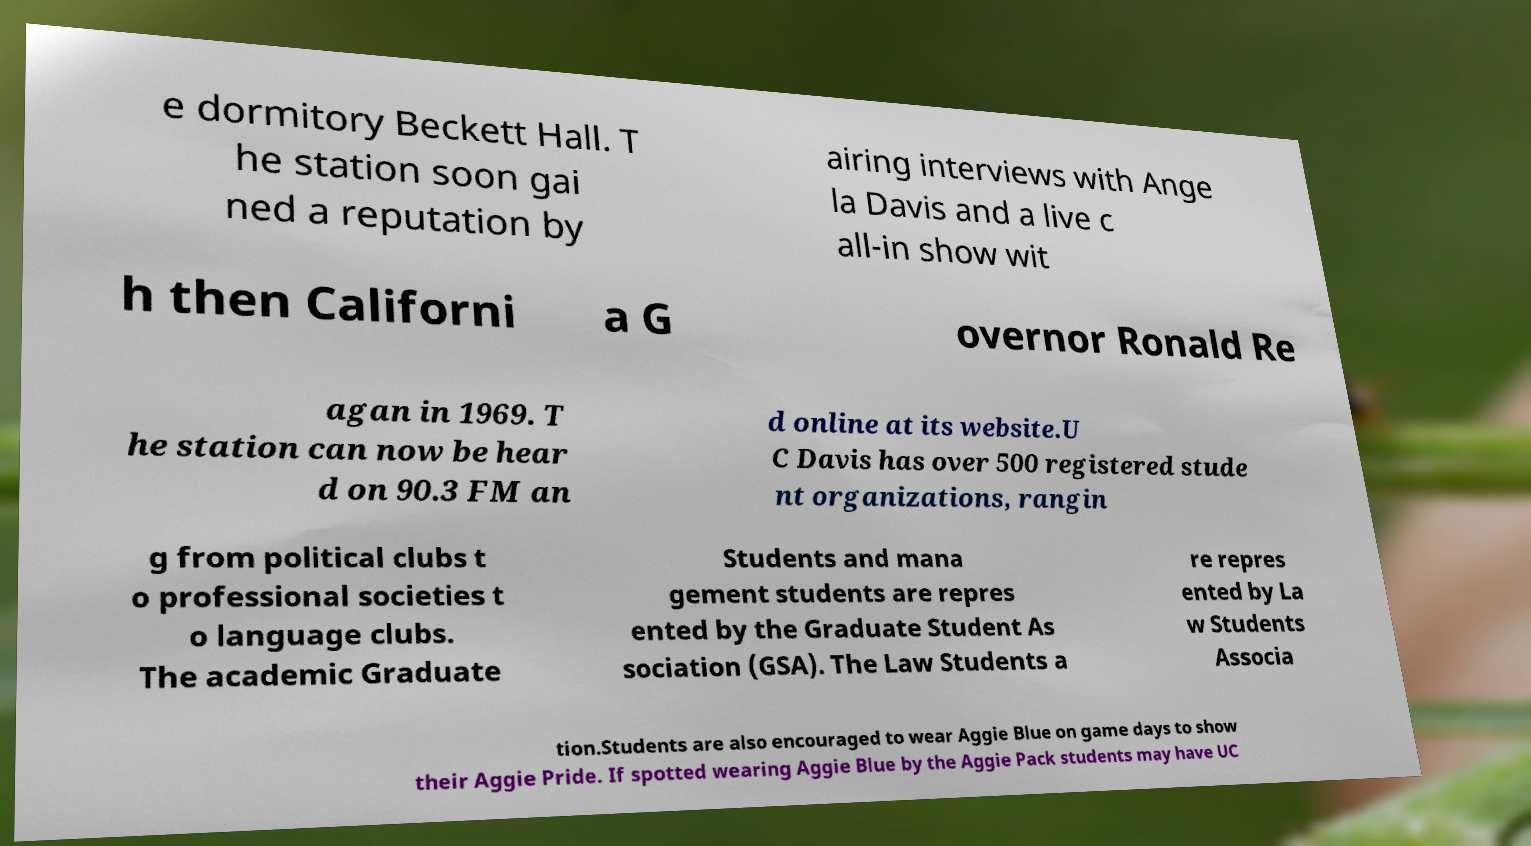Could you extract and type out the text from this image? e dormitory Beckett Hall. T he station soon gai ned a reputation by airing interviews with Ange la Davis and a live c all-in show wit h then Californi a G overnor Ronald Re agan in 1969. T he station can now be hear d on 90.3 FM an d online at its website.U C Davis has over 500 registered stude nt organizations, rangin g from political clubs t o professional societies t o language clubs. The academic Graduate Students and mana gement students are repres ented by the Graduate Student As sociation (GSA). The Law Students a re repres ented by La w Students Associa tion.Students are also encouraged to wear Aggie Blue on game days to show their Aggie Pride. If spotted wearing Aggie Blue by the Aggie Pack students may have UC 